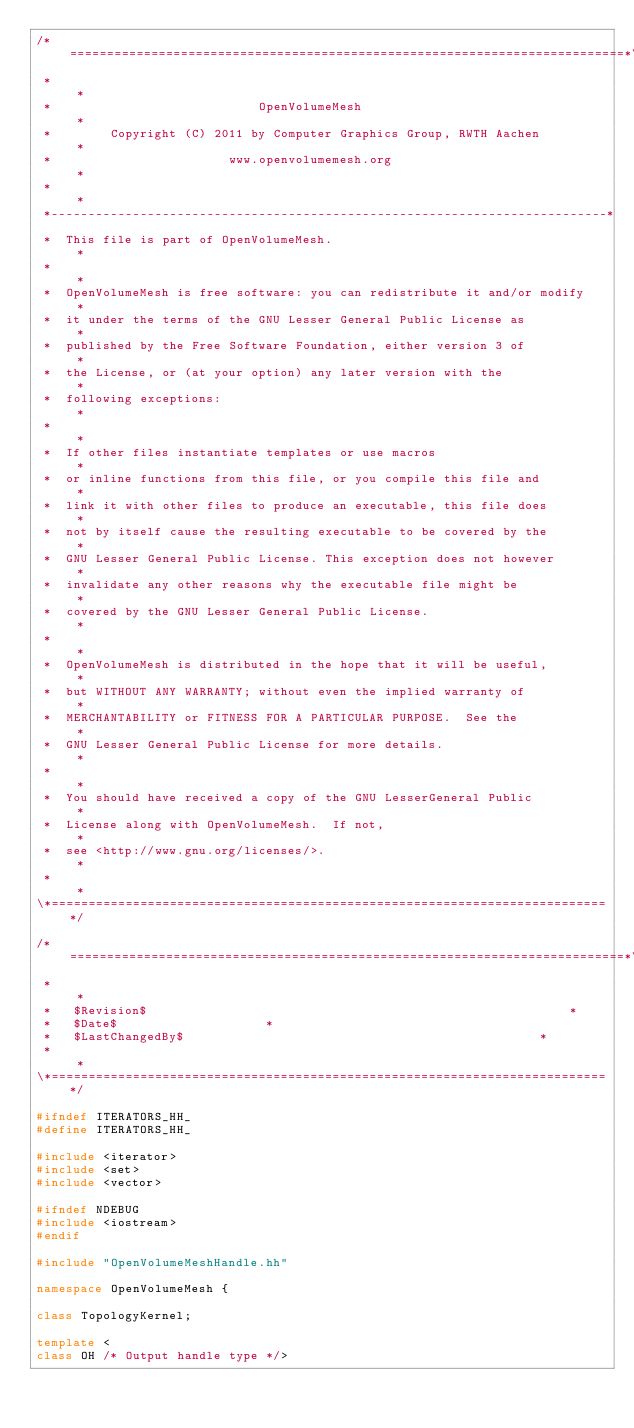Convert code to text. <code><loc_0><loc_0><loc_500><loc_500><_C++_>/*===========================================================================*\
 *                                                                           *
 *                            OpenVolumeMesh                                 *
 *        Copyright (C) 2011 by Computer Graphics Group, RWTH Aachen         *
 *                        www.openvolumemesh.org                             *
 *                                                                           *
 *---------------------------------------------------------------------------*
 *  This file is part of OpenVolumeMesh.                                     *
 *                                                                           *
 *  OpenVolumeMesh is free software: you can redistribute it and/or modify   *
 *  it under the terms of the GNU Lesser General Public License as           *
 *  published by the Free Software Foundation, either version 3 of           *
 *  the License, or (at your option) any later version with the              *
 *  following exceptions:                                                    *
 *                                                                           *
 *  If other files instantiate templates or use macros                       *
 *  or inline functions from this file, or you compile this file and         *
 *  link it with other files to produce an executable, this file does        *
 *  not by itself cause the resulting executable to be covered by the        *
 *  GNU Lesser General Public License. This exception does not however       *
 *  invalidate any other reasons why the executable file might be            *
 *  covered by the GNU Lesser General Public License.                        *
 *                                                                           *
 *  OpenVolumeMesh is distributed in the hope that it will be useful,        *
 *  but WITHOUT ANY WARRANTY; without even the implied warranty of           *
 *  MERCHANTABILITY or FITNESS FOR A PARTICULAR PURPOSE.  See the            *
 *  GNU Lesser General Public License for more details.                      *
 *                                                                           *
 *  You should have received a copy of the GNU LesserGeneral Public          *
 *  License along with OpenVolumeMesh.  If not,                              *
 *  see <http://www.gnu.org/licenses/>.                                      *
 *                                                                           *
\*===========================================================================*/

/*===========================================================================*\
 *                                                                           *
 *   $Revision$                                                         *
 *   $Date$                    *
 *   $LastChangedBy$                                                *
 *                                                                           *
\*===========================================================================*/

#ifndef ITERATORS_HH_
#define ITERATORS_HH_

#include <iterator>
#include <set>
#include <vector>

#ifndef NDEBUG
#include <iostream>
#endif

#include "OpenVolumeMeshHandle.hh"

namespace OpenVolumeMesh {

class TopologyKernel;

template <
class OH /* Output handle type */></code> 